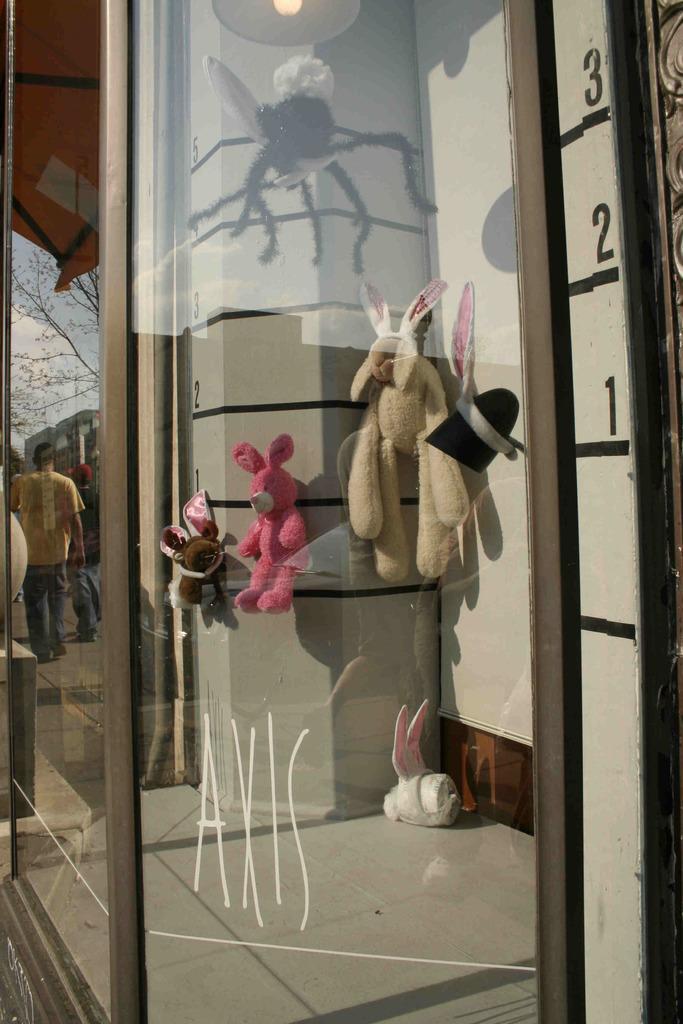How would you summarize this image in a sentence or two? In this image I can see the glass surface and through the glass I can see few soft toys. On the glass I can see the reflection of few trees, few persons, few buildings and the sky. 